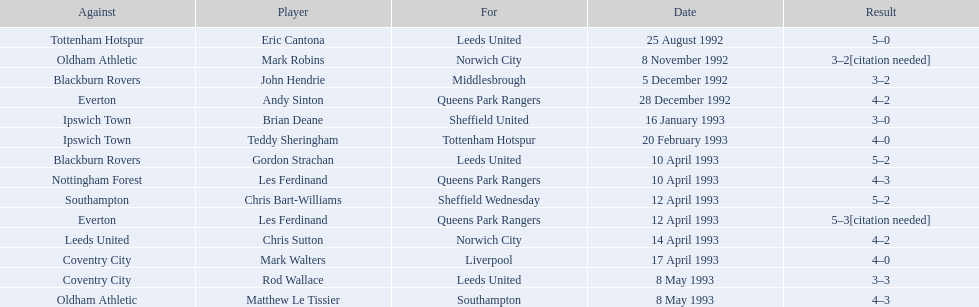Who are all the players? Eric Cantona, Mark Robins, John Hendrie, Andy Sinton, Brian Deane, Teddy Sheringham, Gordon Strachan, Les Ferdinand, Chris Bart-Williams, Les Ferdinand, Chris Sutton, Mark Walters, Rod Wallace, Matthew Le Tissier. What were their results? 5–0, 3–2[citation needed], 3–2, 4–2, 3–0, 4–0, 5–2, 4–3, 5–2, 5–3[citation needed], 4–2, 4–0, 3–3, 4–3. Which player tied with mark robins? John Hendrie. 